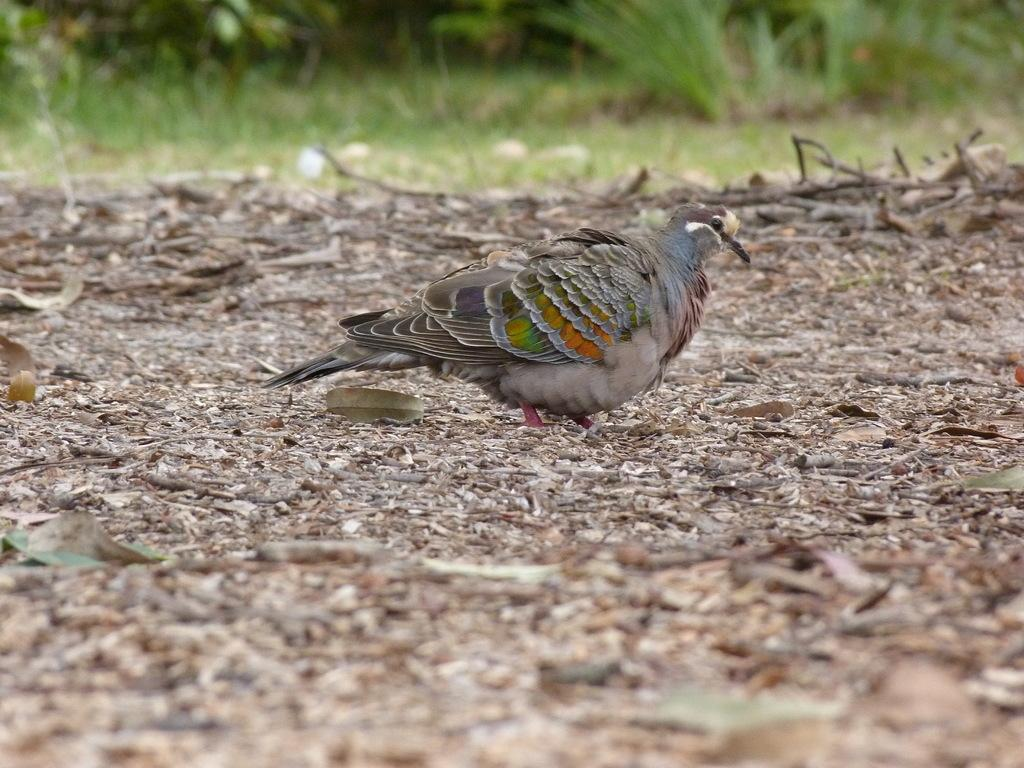What type of animal can be seen in the image? There is a bird in the image. What can be found on the ground in the image? There are leaves on the ground in the image. How would you describe the background of the image? The background of the image is blurred. What type of fear does the bird exhibit in the image? There is no indication of fear in the image; the bird appears to be in its natural environment. Can you see any magic happening in the image? There is no magic present in the image; it is a realistic depiction of a bird and its surroundings. 